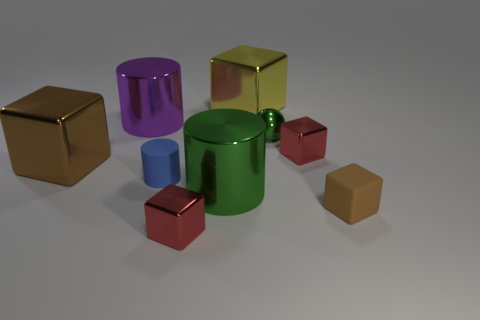Add 1 small brown balls. How many objects exist? 10 Subtract all red cubes. How many cubes are left? 3 Subtract all big green shiny cylinders. How many cylinders are left? 2 Subtract 0 green blocks. How many objects are left? 9 Subtract all cylinders. How many objects are left? 6 Subtract 3 cylinders. How many cylinders are left? 0 Subtract all yellow cylinders. Subtract all brown cubes. How many cylinders are left? 3 Subtract all red cylinders. How many purple balls are left? 0 Subtract all large metal things. Subtract all tiny cylinders. How many objects are left? 4 Add 6 green balls. How many green balls are left? 7 